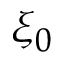Convert formula to latex. <formula><loc_0><loc_0><loc_500><loc_500>\xi _ { 0 }</formula> 